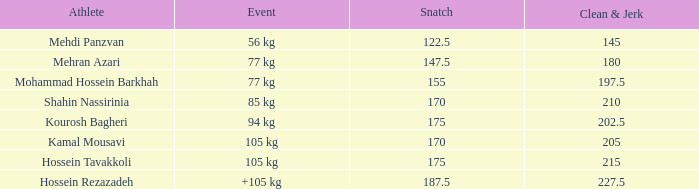I'm looking to parse the entire table for insights. Could you assist me with that? {'header': ['Athlete', 'Event', 'Snatch', 'Clean & Jerk'], 'rows': [['Mehdi Panzvan', '56 kg', '122.5', '145'], ['Mehran Azari', '77 kg', '147.5', '180'], ['Mohammad Hossein Barkhah', '77 kg', '155', '197.5'], ['Shahin Nassirinia', '85 kg', '170', '210'], ['Kourosh Bagheri', '94 kg', '175', '202.5'], ['Kamal Mousavi', '105 kg', '170', '205'], ['Hossein Tavakkoli', '105 kg', '175', '215'], ['Hossein Rezazadeh', '+105 kg', '187.5', '227.5']]} What is the total that had an event of +105 kg and clean & jerk less than 227.5? 0.0. 